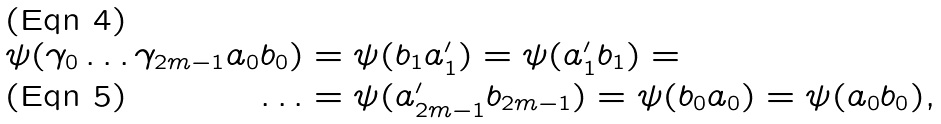<formula> <loc_0><loc_0><loc_500><loc_500>\psi ( \gamma _ { 0 } \dots \gamma _ { 2 m - 1 } a _ { 0 } b _ { 0 } ) & = \psi ( b _ { 1 } a _ { 1 } ^ { \prime } ) = \psi ( a _ { 1 } ^ { \prime } b _ { 1 } ) = \\ \dots & = \psi ( a _ { 2 m - 1 } ^ { \prime } b _ { 2 m - 1 } ) = \psi ( b _ { 0 } a _ { 0 } ) = \psi ( a _ { 0 } b _ { 0 } ) ,</formula> 